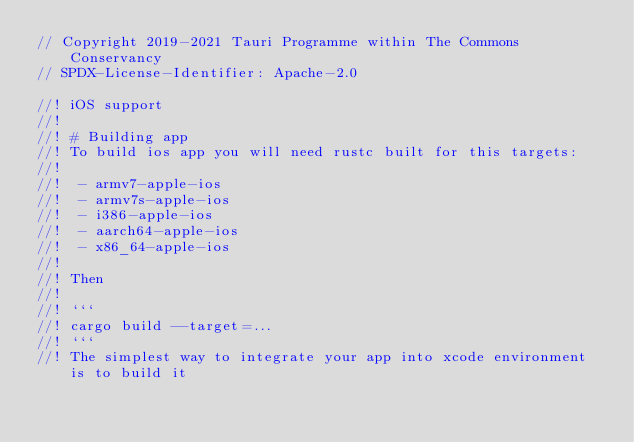Convert code to text. <code><loc_0><loc_0><loc_500><loc_500><_Rust_>// Copyright 2019-2021 Tauri Programme within The Commons Conservancy
// SPDX-License-Identifier: Apache-2.0

//! iOS support
//!
//! # Building app
//! To build ios app you will need rustc built for this targets:
//!
//!  - armv7-apple-ios
//!  - armv7s-apple-ios
//!  - i386-apple-ios
//!  - aarch64-apple-ios
//!  - x86_64-apple-ios
//!
//! Then
//!
//! ```
//! cargo build --target=...
//! ```
//! The simplest way to integrate your app into xcode environment is to build it</code> 